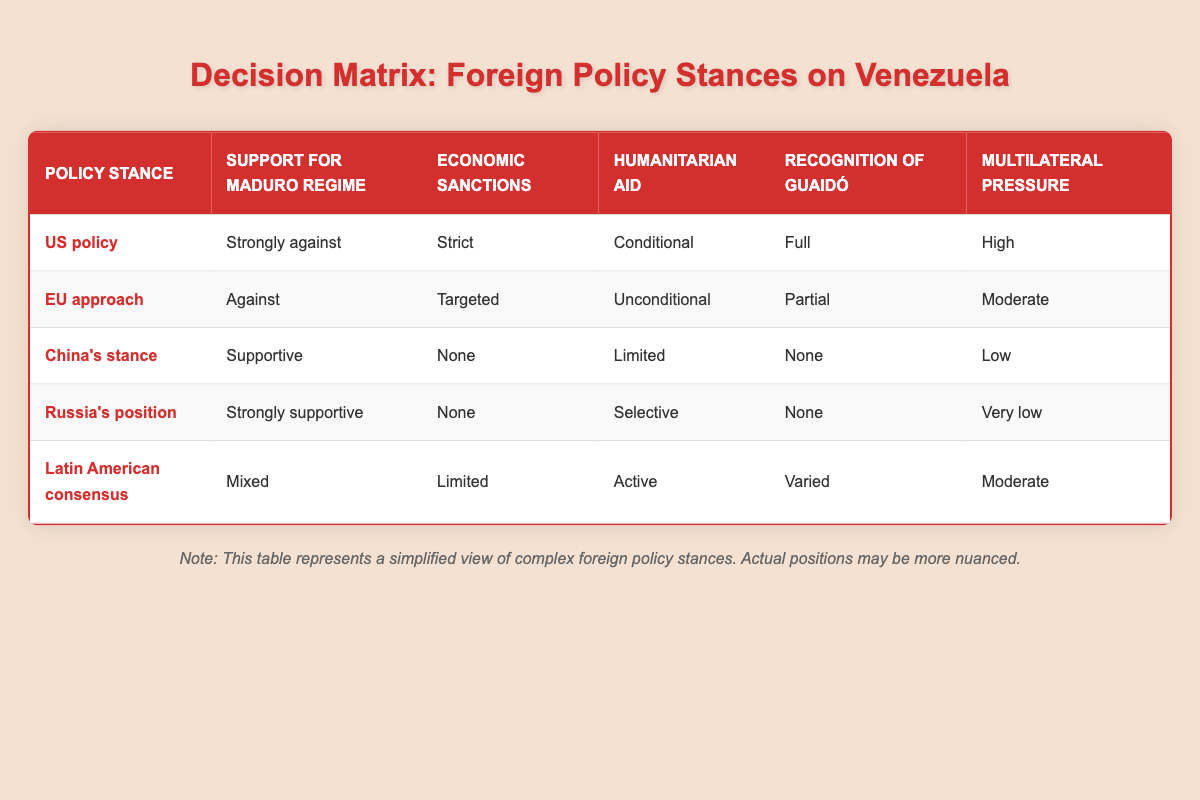What is the US policy stance on humanitarian aid? In the table, the US policy stance states "Conditional" for humanitarian aid, indicating that any aid provided is contingent on certain conditions being met.
Answer: Conditional Which policy stance has the strictest economic sanctions? From the table, the US policy stance has "Strict" economic sanctions, which is more stringent than the other stances listed.
Answer: Strict Do both Russia's position and China's stance support the Maduro regime? Yes, Russia's position states "Strongly supportive" while China's stance states "Supportive," indicating that both are in favor of the Maduro regime.
Answer: Yes What is the difference in multilateral pressure between the US policy and the EU approach? The US policy has a "High" level of multilateral pressure, while the EU approach has a "Moderate" level. The difference is one level, indicating that the US exerts more influence.
Answer: One level Which policy stance has mixed support for the Maduro regime? The Latin American consensus stance has "Mixed" support for the Maduro regime, indicating varying opinions within that group.
Answer: Mixed Is the recognition of Guaidó full under the US policy stance? Yes, the US policy stance states "Full" recognition of Guaidó, indicating complete support for his recognition as a legitimate leader.
Answer: Yes What are the humanitarian aid policies of the EU approach and Russia's position combined? The EU approach has "Unconditional" humanitarian aid while Russia's position has "Selective." This suggests a disparity in how aid is provided by these two stances; combining them indicates a contrasting approach of blanket vs. conditional support.
Answer: Contrasting approaches How many policy stances recognize Guaidó in any capacity? The stances that recognize Guaidó include the US policy ("Full"), EU approach ("Partial"), and Latin American consensus ("Varied"). Adding those up gives a total of three different policies that recognize him.
Answer: Three What stance has the least economic sanctions? According to the table, both China's stance and Russia's position have "None" under economic sanctions, indicating no sanctions imposed.
Answer: None 